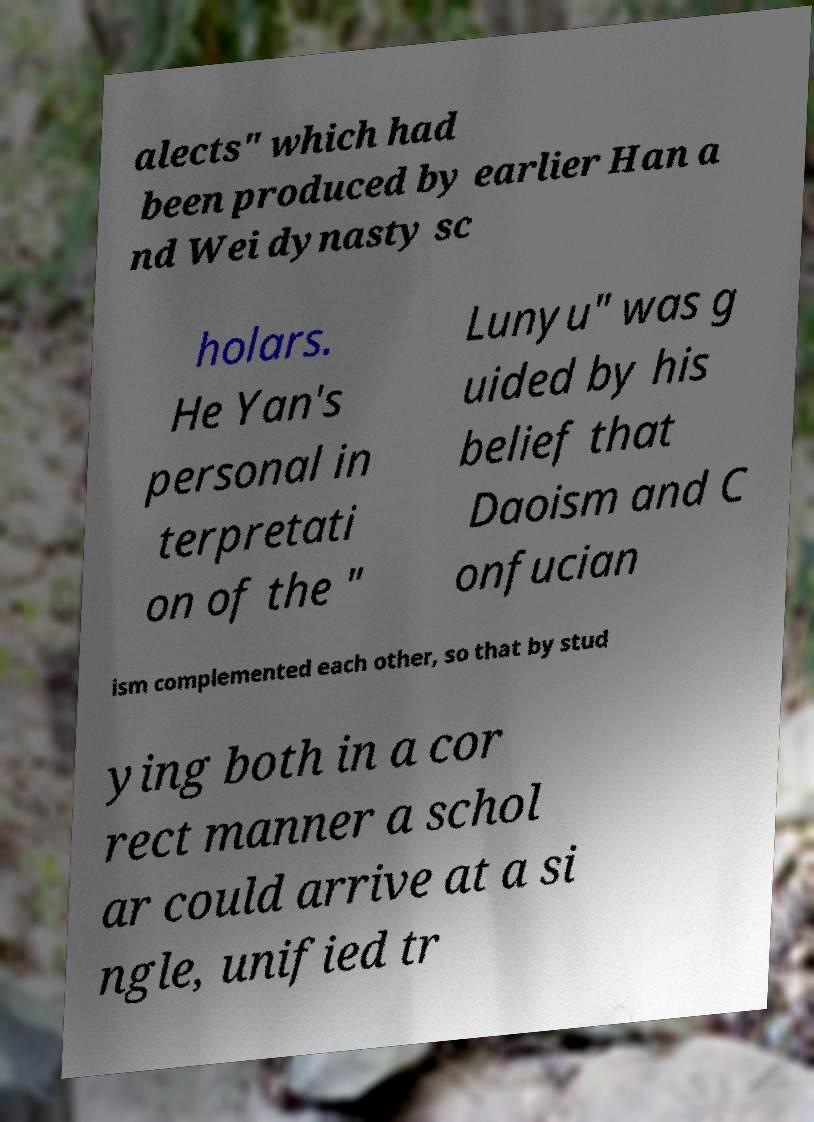What messages or text are displayed in this image? I need them in a readable, typed format. alects" which had been produced by earlier Han a nd Wei dynasty sc holars. He Yan's personal in terpretati on of the " Lunyu" was g uided by his belief that Daoism and C onfucian ism complemented each other, so that by stud ying both in a cor rect manner a schol ar could arrive at a si ngle, unified tr 